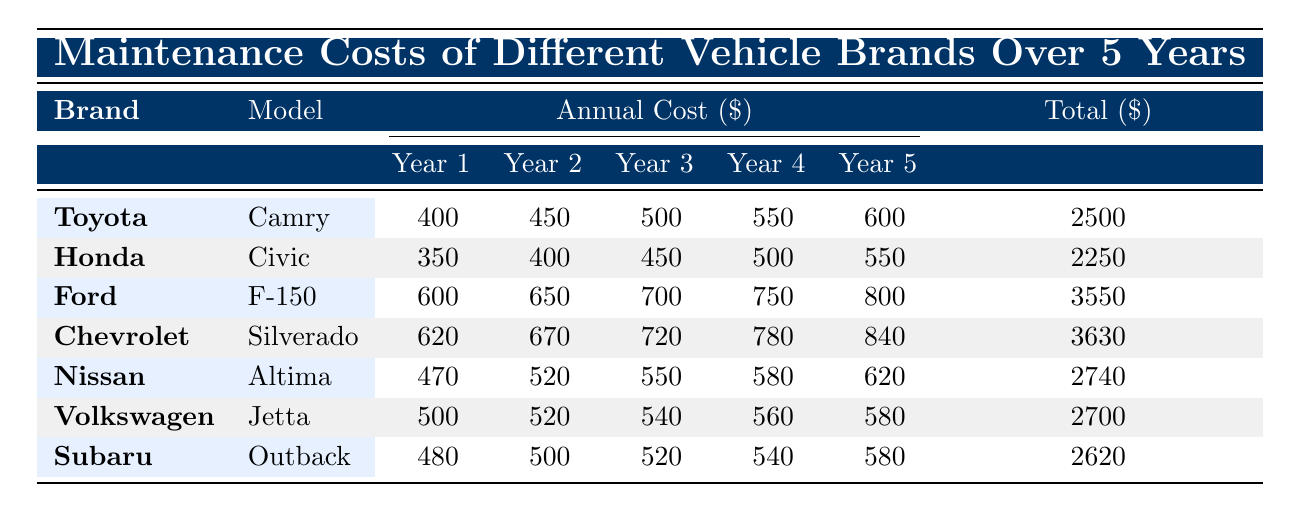What is the annual maintenance cost for the Toyota Camry in Year 3? In the table, find the row for Toyota Camry and look under the Year 3 column. The value listed there is 500.
Answer: 500 What is the total maintenance cost for the Honda Civic over 5 years? Locate the row for Honda Civic and find the Total Cost column. The value listed there is 2250.
Answer: 2250 Which vehicle brand has the highest maintenance cost in Year 2? Review the Year 2 column for all brands. The highest value is 670, which corresponds to Chevrolet Silverado.
Answer: Chevrolet What is the average maintenance cost across all years for the Ford F-150? First, sum the annual costs: 600 + 650 + 700 + 750 + 800 = 3500. Since there are 5 years, divide this total by 5: 3500 / 5 = 700.
Answer: 700 Is the total maintenance cost for the Nissan Altima less than that of the Subaru Outback? Compare the Total Cost values for both vehicles: Nissan Altima is 2740 and Subaru Outback is 2620. Since 2620 is less than 2740, the statement is true.
Answer: Yes What is the difference in total maintenance costs between the Chevrolet Silverado and the Ford F-150? The Total Cost for Chevrolet Silverado is 3630 and for Ford F-150 is 3550. Now, calculate the difference: 3630 - 3550 = 80.
Answer: 80 Which brand has the lowest Year 1 maintenance cost? Look at the Year 1 column and find the smallest value. The lowest value is 350, corresponding to Honda Civic.
Answer: Honda If we were to rank the vehicles by their total maintenance costs from lowest to highest, what would be the third vehicle on this list? List the total costs: Honda Civic (2250), Toyota Camry (2500), Volkswagen Jetta (2700), Subaru Outback (2620), Nissan Altima (2740), Ford F-150 (3550), Chevrolet Silverado (3630). The third lowest is Volkswagen Jetta.
Answer: Volkswagen What is the sum of maintenance costs for the Subaru Outback over the first three years? For the Subaru Outback, the costs for the first three years are 480 + 500 + 520. Adding these gives 480 + 500 = 980, then 980 + 520 = 1500.
Answer: 1500 